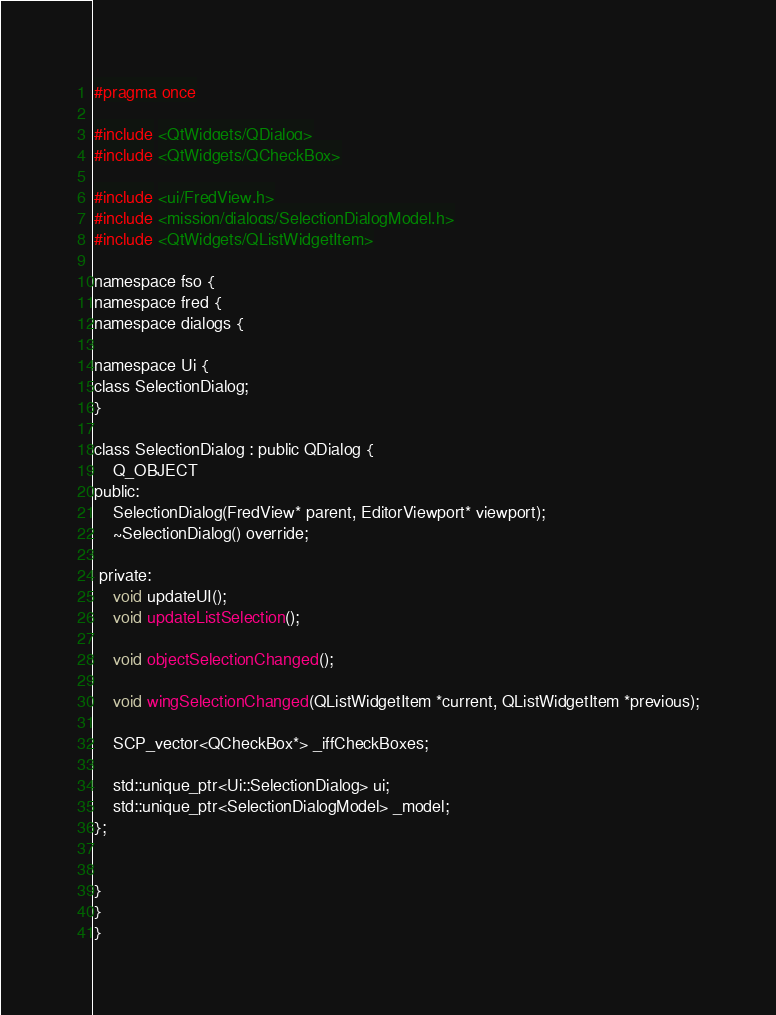<code> <loc_0><loc_0><loc_500><loc_500><_C_>#pragma once

#include <QtWidgets/QDialog>
#include <QtWidgets/QCheckBox>

#include <ui/FredView.h>
#include <mission/dialogs/SelectionDialogModel.h>
#include <QtWidgets/QListWidgetItem>

namespace fso {
namespace fred {
namespace dialogs {

namespace Ui {
class SelectionDialog;
}

class SelectionDialog : public QDialog {
	Q_OBJECT
public:
	SelectionDialog(FredView* parent, EditorViewport* viewport);
	~SelectionDialog() override;

 private:
	void updateUI();
	void updateListSelection();

	void objectSelectionChanged();

	void wingSelectionChanged(QListWidgetItem *current, QListWidgetItem *previous);

	SCP_vector<QCheckBox*> _iffCheckBoxes;

	std::unique_ptr<Ui::SelectionDialog> ui;
	std::unique_ptr<SelectionDialogModel> _model;
};


}
}
}


</code> 